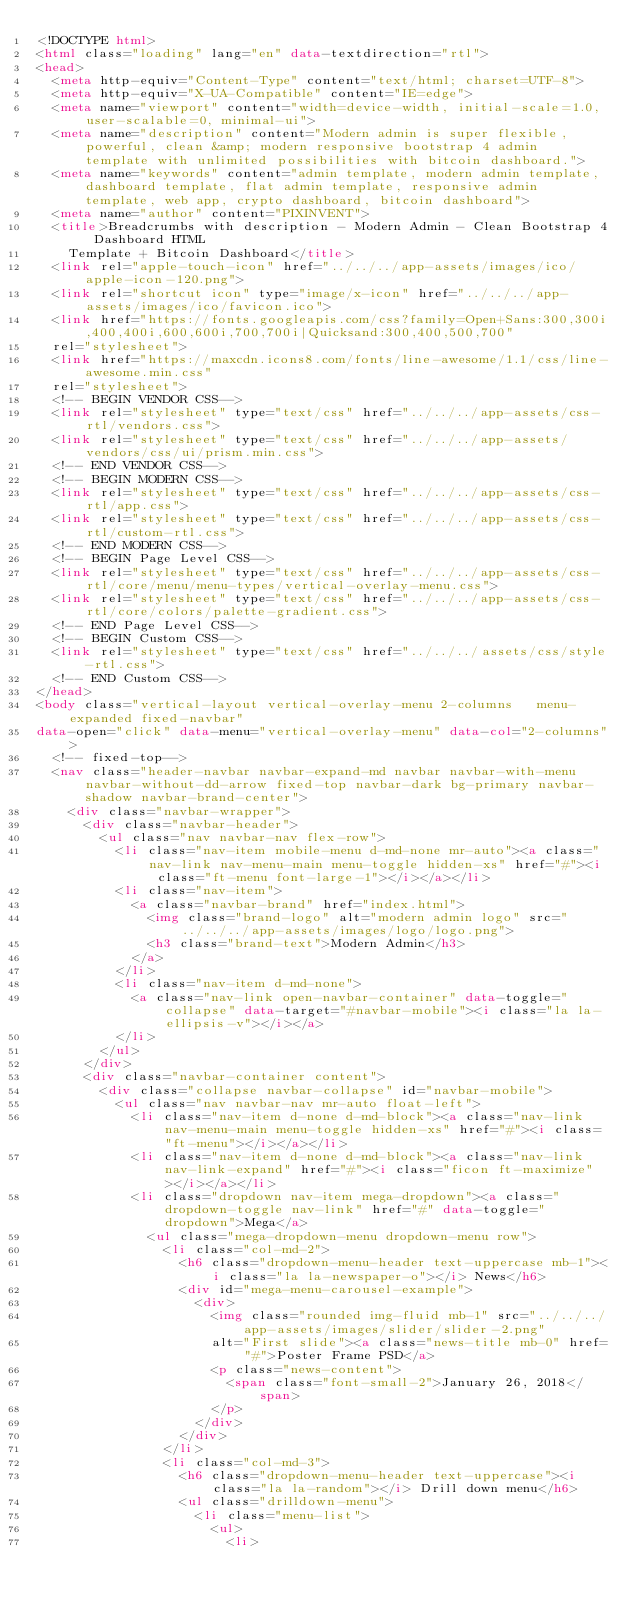<code> <loc_0><loc_0><loc_500><loc_500><_HTML_><!DOCTYPE html>
<html class="loading" lang="en" data-textdirection="rtl">
<head>
  <meta http-equiv="Content-Type" content="text/html; charset=UTF-8">
  <meta http-equiv="X-UA-Compatible" content="IE=edge">
  <meta name="viewport" content="width=device-width, initial-scale=1.0, user-scalable=0, minimal-ui">
  <meta name="description" content="Modern admin is super flexible, powerful, clean &amp; modern responsive bootstrap 4 admin template with unlimited possibilities with bitcoin dashboard.">
  <meta name="keywords" content="admin template, modern admin template, dashboard template, flat admin template, responsive admin template, web app, crypto dashboard, bitcoin dashboard">
  <meta name="author" content="PIXINVENT">
  <title>Breadcrumbs with description - Modern Admin - Clean Bootstrap 4 Dashboard HTML
    Template + Bitcoin Dashboard</title>
  <link rel="apple-touch-icon" href="../../../app-assets/images/ico/apple-icon-120.png">
  <link rel="shortcut icon" type="image/x-icon" href="../../../app-assets/images/ico/favicon.ico">
  <link href="https://fonts.googleapis.com/css?family=Open+Sans:300,300i,400,400i,600,600i,700,700i|Quicksand:300,400,500,700"
  rel="stylesheet">
  <link href="https://maxcdn.icons8.com/fonts/line-awesome/1.1/css/line-awesome.min.css"
  rel="stylesheet">
  <!-- BEGIN VENDOR CSS-->
  <link rel="stylesheet" type="text/css" href="../../../app-assets/css-rtl/vendors.css">
  <link rel="stylesheet" type="text/css" href="../../../app-assets/vendors/css/ui/prism.min.css">
  <!-- END VENDOR CSS-->
  <!-- BEGIN MODERN CSS-->
  <link rel="stylesheet" type="text/css" href="../../../app-assets/css-rtl/app.css">
  <link rel="stylesheet" type="text/css" href="../../../app-assets/css-rtl/custom-rtl.css">
  <!-- END MODERN CSS-->
  <!-- BEGIN Page Level CSS-->
  <link rel="stylesheet" type="text/css" href="../../../app-assets/css-rtl/core/menu/menu-types/vertical-overlay-menu.css">
  <link rel="stylesheet" type="text/css" href="../../../app-assets/css-rtl/core/colors/palette-gradient.css">
  <!-- END Page Level CSS-->
  <!-- BEGIN Custom CSS-->
  <link rel="stylesheet" type="text/css" href="../../../assets/css/style-rtl.css">
  <!-- END Custom CSS-->
</head>
<body class="vertical-layout vertical-overlay-menu 2-columns   menu-expanded fixed-navbar"
data-open="click" data-menu="vertical-overlay-menu" data-col="2-columns">
  <!-- fixed-top-->
  <nav class="header-navbar navbar-expand-md navbar navbar-with-menu navbar-without-dd-arrow fixed-top navbar-dark bg-primary navbar-shadow navbar-brand-center">
    <div class="navbar-wrapper">
      <div class="navbar-header">
        <ul class="nav navbar-nav flex-row">
          <li class="nav-item mobile-menu d-md-none mr-auto"><a class="nav-link nav-menu-main menu-toggle hidden-xs" href="#"><i class="ft-menu font-large-1"></i></a></li>
          <li class="nav-item">
            <a class="navbar-brand" href="index.html">
              <img class="brand-logo" alt="modern admin logo" src="../../../app-assets/images/logo/logo.png">
              <h3 class="brand-text">Modern Admin</h3>
            </a>
          </li>
          <li class="nav-item d-md-none">
            <a class="nav-link open-navbar-container" data-toggle="collapse" data-target="#navbar-mobile"><i class="la la-ellipsis-v"></i></a>
          </li>
        </ul>
      </div>
      <div class="navbar-container content">
        <div class="collapse navbar-collapse" id="navbar-mobile">
          <ul class="nav navbar-nav mr-auto float-left">
            <li class="nav-item d-none d-md-block"><a class="nav-link nav-menu-main menu-toggle hidden-xs" href="#"><i class="ft-menu"></i></a></li>
            <li class="nav-item d-none d-md-block"><a class="nav-link nav-link-expand" href="#"><i class="ficon ft-maximize"></i></a></li>
            <li class="dropdown nav-item mega-dropdown"><a class="dropdown-toggle nav-link" href="#" data-toggle="dropdown">Mega</a>
              <ul class="mega-dropdown-menu dropdown-menu row">
                <li class="col-md-2">
                  <h6 class="dropdown-menu-header text-uppercase mb-1"><i class="la la-newspaper-o"></i> News</h6>
                  <div id="mega-menu-carousel-example">
                    <div>
                      <img class="rounded img-fluid mb-1" src="../../../app-assets/images/slider/slider-2.png"
                      alt="First slide"><a class="news-title mb-0" href="#">Poster Frame PSD</a>
                      <p class="news-content">
                        <span class="font-small-2">January 26, 2018</span>
                      </p>
                    </div>
                  </div>
                </li>
                <li class="col-md-3">
                  <h6 class="dropdown-menu-header text-uppercase"><i class="la la-random"></i> Drill down menu</h6>
                  <ul class="drilldown-menu">
                    <li class="menu-list">
                      <ul>
                        <li></code> 